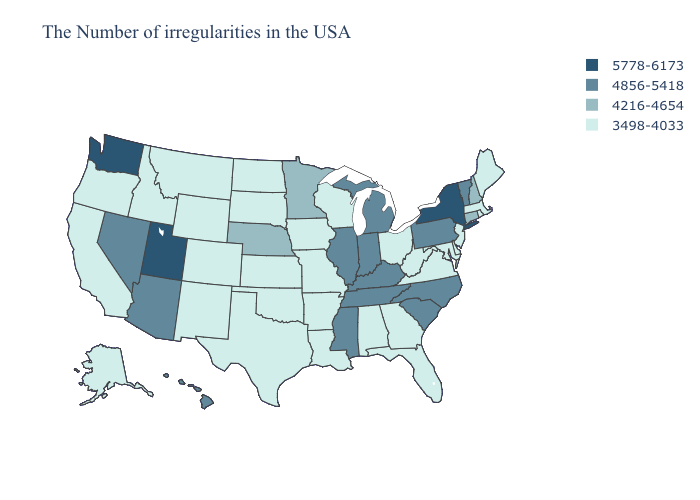Which states have the lowest value in the USA?
Quick response, please. Maine, Massachusetts, Rhode Island, New Jersey, Delaware, Maryland, Virginia, West Virginia, Ohio, Florida, Georgia, Alabama, Wisconsin, Louisiana, Missouri, Arkansas, Iowa, Kansas, Oklahoma, Texas, South Dakota, North Dakota, Wyoming, Colorado, New Mexico, Montana, Idaho, California, Oregon, Alaska. Does Utah have the highest value in the USA?
Give a very brief answer. Yes. Does Arizona have the lowest value in the USA?
Concise answer only. No. What is the lowest value in the USA?
Keep it brief. 3498-4033. What is the value of Massachusetts?
Quick response, please. 3498-4033. Among the states that border Tennessee , which have the highest value?
Short answer required. North Carolina, Kentucky, Mississippi. What is the value of Nevada?
Short answer required. 4856-5418. Does New Jersey have a lower value than Georgia?
Keep it brief. No. Name the states that have a value in the range 5778-6173?
Quick response, please. New York, Utah, Washington. What is the lowest value in the USA?
Be succinct. 3498-4033. Does Minnesota have the lowest value in the MidWest?
Be succinct. No. Among the states that border Idaho , which have the highest value?
Quick response, please. Utah, Washington. Does Arizona have the lowest value in the West?
Short answer required. No. Which states have the lowest value in the West?
Concise answer only. Wyoming, Colorado, New Mexico, Montana, Idaho, California, Oregon, Alaska. 